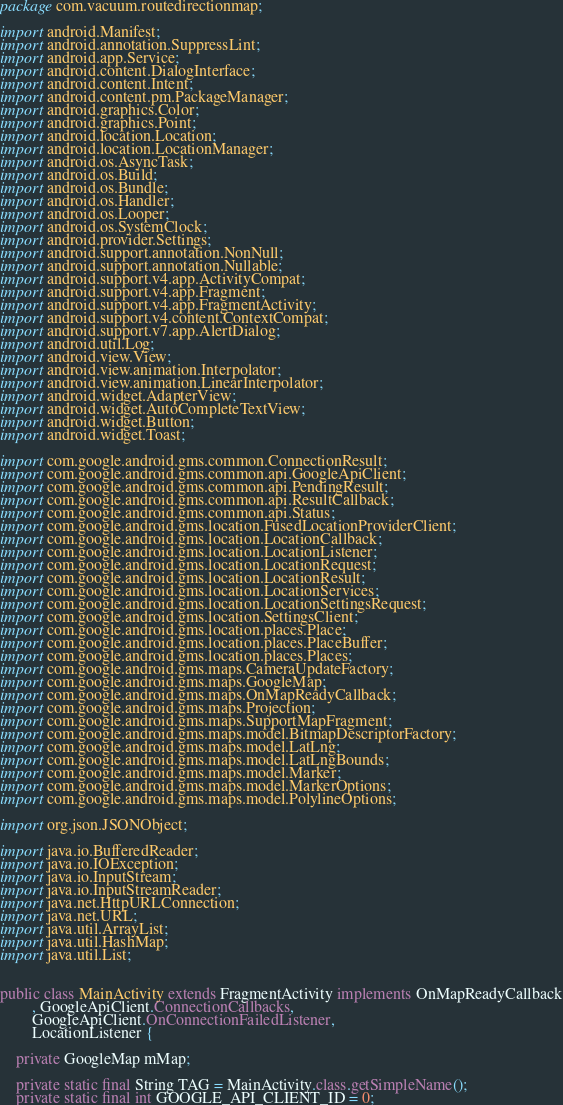<code> <loc_0><loc_0><loc_500><loc_500><_Java_>package com.vacuum.routedirectionmap;

import android.Manifest;
import android.annotation.SuppressLint;
import android.app.Service;
import android.content.DialogInterface;
import android.content.Intent;
import android.content.pm.PackageManager;
import android.graphics.Color;
import android.graphics.Point;
import android.location.Location;
import android.location.LocationManager;
import android.os.AsyncTask;
import android.os.Build;
import android.os.Bundle;
import android.os.Handler;
import android.os.Looper;
import android.os.SystemClock;
import android.provider.Settings;
import android.support.annotation.NonNull;
import android.support.annotation.Nullable;
import android.support.v4.app.ActivityCompat;
import android.support.v4.app.Fragment;
import android.support.v4.app.FragmentActivity;
import android.support.v4.content.ContextCompat;
import android.support.v7.app.AlertDialog;
import android.util.Log;
import android.view.View;
import android.view.animation.Interpolator;
import android.view.animation.LinearInterpolator;
import android.widget.AdapterView;
import android.widget.AutoCompleteTextView;
import android.widget.Button;
import android.widget.Toast;

import com.google.android.gms.common.ConnectionResult;
import com.google.android.gms.common.api.GoogleApiClient;
import com.google.android.gms.common.api.PendingResult;
import com.google.android.gms.common.api.ResultCallback;
import com.google.android.gms.common.api.Status;
import com.google.android.gms.location.FusedLocationProviderClient;
import com.google.android.gms.location.LocationCallback;
import com.google.android.gms.location.LocationListener;
import com.google.android.gms.location.LocationRequest;
import com.google.android.gms.location.LocationResult;
import com.google.android.gms.location.LocationServices;
import com.google.android.gms.location.LocationSettingsRequest;
import com.google.android.gms.location.SettingsClient;
import com.google.android.gms.location.places.Place;
import com.google.android.gms.location.places.PlaceBuffer;
import com.google.android.gms.location.places.Places;
import com.google.android.gms.maps.CameraUpdateFactory;
import com.google.android.gms.maps.GoogleMap;
import com.google.android.gms.maps.OnMapReadyCallback;
import com.google.android.gms.maps.Projection;
import com.google.android.gms.maps.SupportMapFragment;
import com.google.android.gms.maps.model.BitmapDescriptorFactory;
import com.google.android.gms.maps.model.LatLng;
import com.google.android.gms.maps.model.LatLngBounds;
import com.google.android.gms.maps.model.Marker;
import com.google.android.gms.maps.model.MarkerOptions;
import com.google.android.gms.maps.model.PolylineOptions;

import org.json.JSONObject;

import java.io.BufferedReader;
import java.io.IOException;
import java.io.InputStream;
import java.io.InputStreamReader;
import java.net.HttpURLConnection;
import java.net.URL;
import java.util.ArrayList;
import java.util.HashMap;
import java.util.List;


public class MainActivity extends FragmentActivity implements OnMapReadyCallback
        , GoogleApiClient.ConnectionCallbacks,
        GoogleApiClient.OnConnectionFailedListener,
        LocationListener {

    private GoogleMap mMap;

    private static final String TAG = MainActivity.class.getSimpleName();
    private static final int GOOGLE_API_CLIENT_ID = 0;</code> 